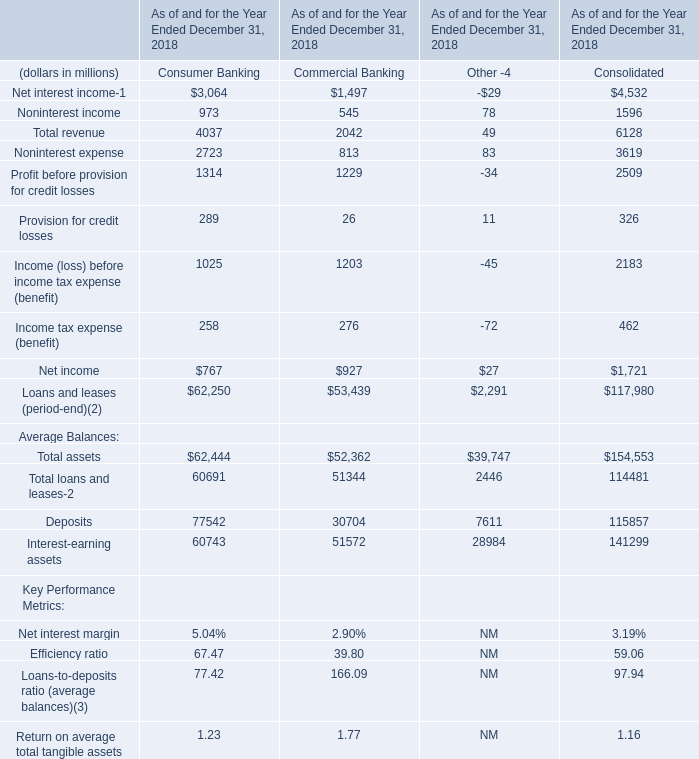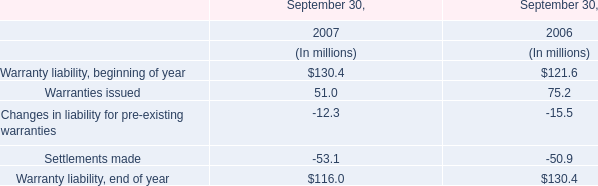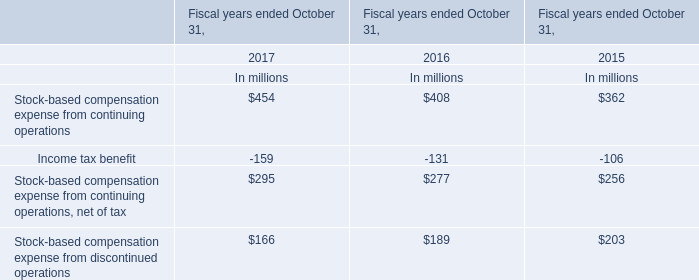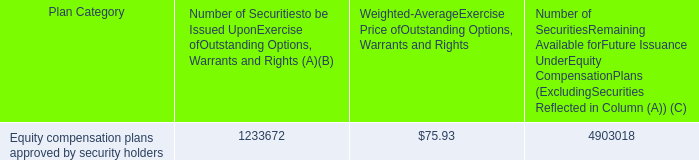what portion of the total number of securities approved by the security holders is issued? 
Computations: (1233672 / (1233672 + 4903018))
Answer: 0.20103. 